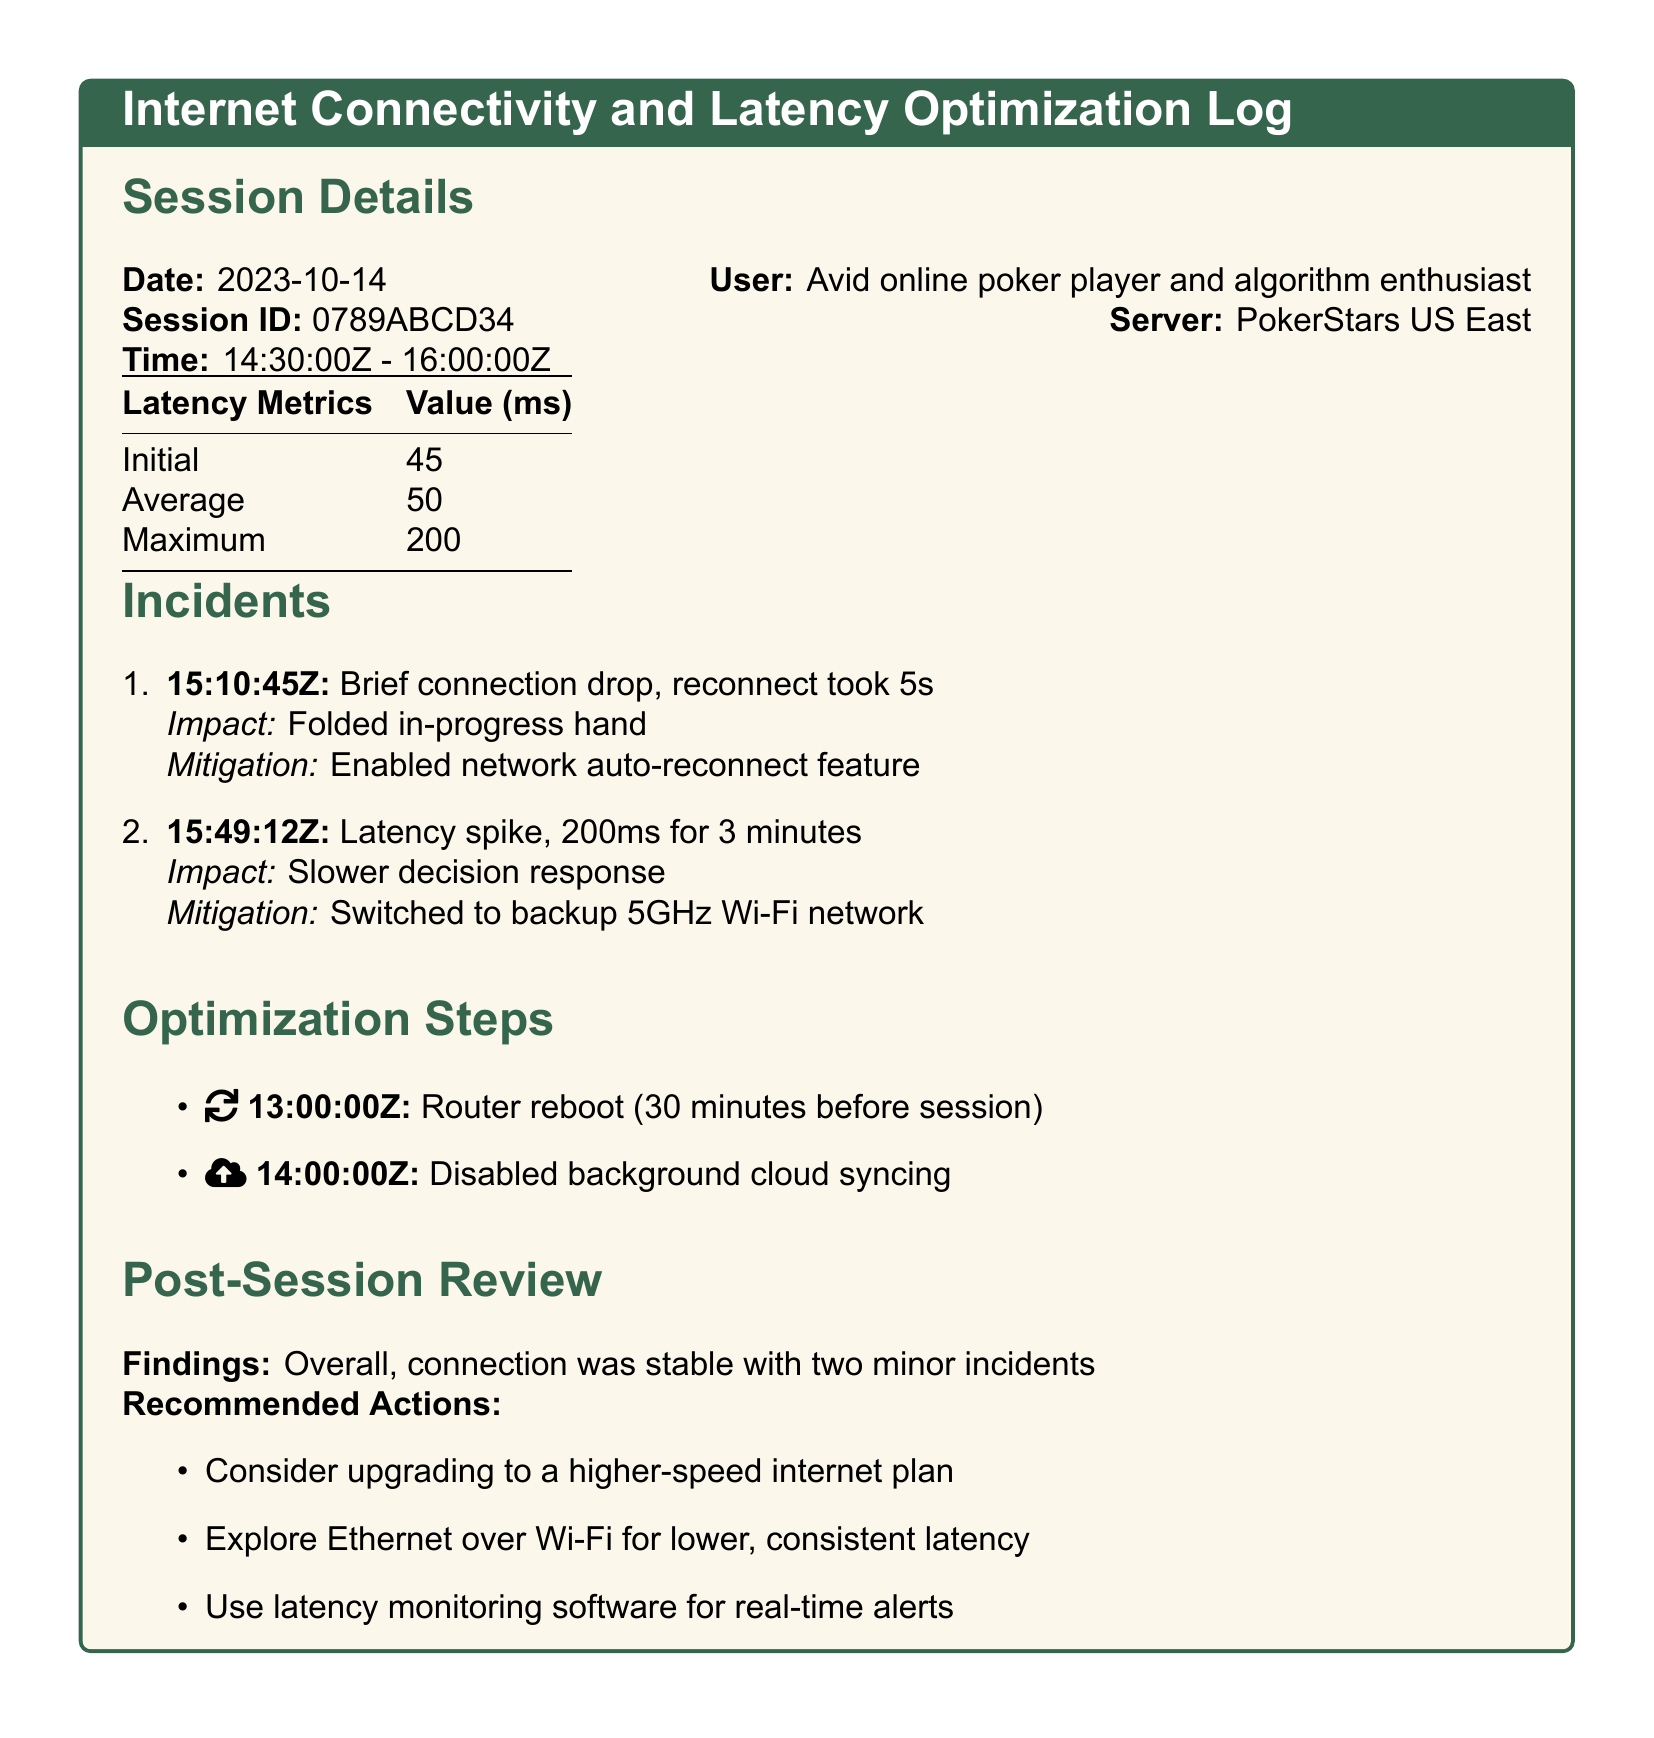What is the session ID? The session ID is a unique identifier for this particular log entry, found in the section labeled "Session Details."
Answer: 0789ABCD34 What was the maximum latency recorded? The maximum latency is the highest measured latency during the session, noted in the latency metrics table.
Answer: 200 What time did the first incident occur? The time of the first incident is listed under the "Incidents" section, detailing when it happened.
Answer: 15:10:45Z What action was taken to mitigate the first incident? The action taken to address the first incident is indicated in the mitigation description for that incident.
Answer: Enabled network auto-reconnect feature What recommendation was made for internet plan? The recommendation regarding the internet plan appears in the "Recommended Actions" section, suggesting an upgrade.
Answer: Higher-speed internet plan What was the average latency during the session? The average latency is presented in the latency metrics table as one of the key performance values.
Answer: 50 What was disabled prior to the session? The document specifies a certain action that was taken before the session began, as noted in the "Optimization Steps" section.
Answer: Background cloud syncing How long did the router reboot take place before the session? The timing of the router reboot is indicated in the optimization steps and details the duration before the session started.
Answer: 30 minutes What was the overall connection finding from the post-session review? The finding from the post-session review summarizes the overall connection performance, as detailed in that section.
Answer: Stable with two minor incidents 